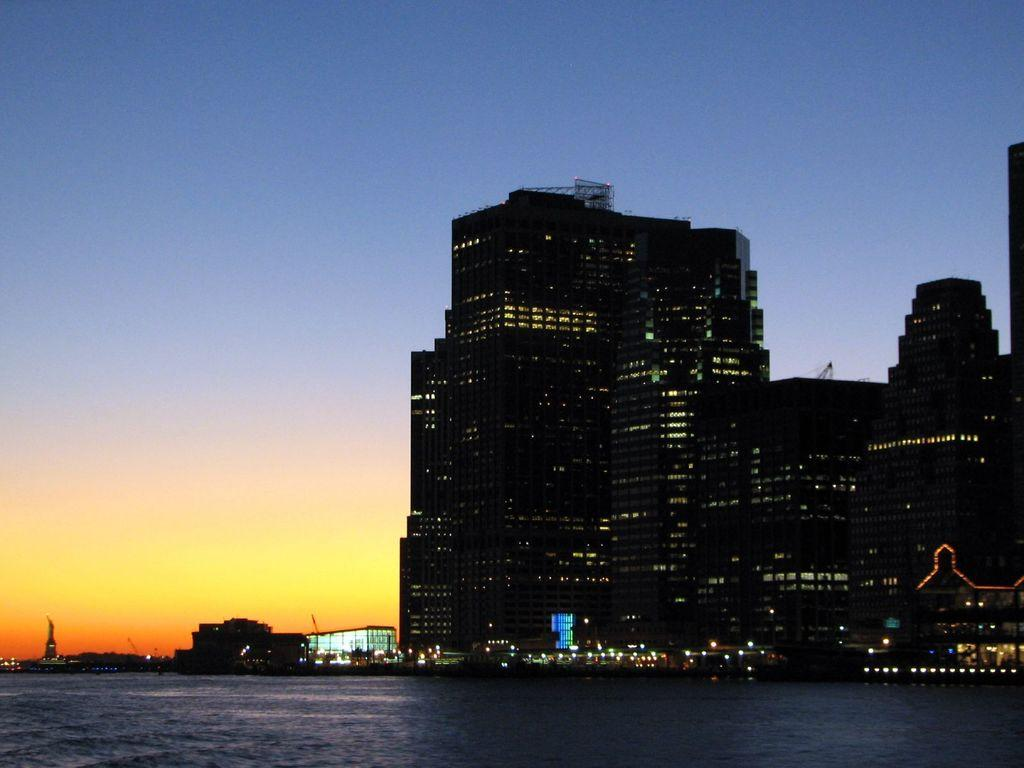What type of natural environment is depicted in the image? There is a sea in the image. What structures can be seen in the background of the image? There are buildings in the background of the image. What is visible in the background of the image besides the buildings? The sky is visible in the background of the image. What type of floor can be seen in the image? There is no floor present in the image, as it features a sea and buildings in the background. Are there any mountains visible in the image? There are no mountains present in the image. 